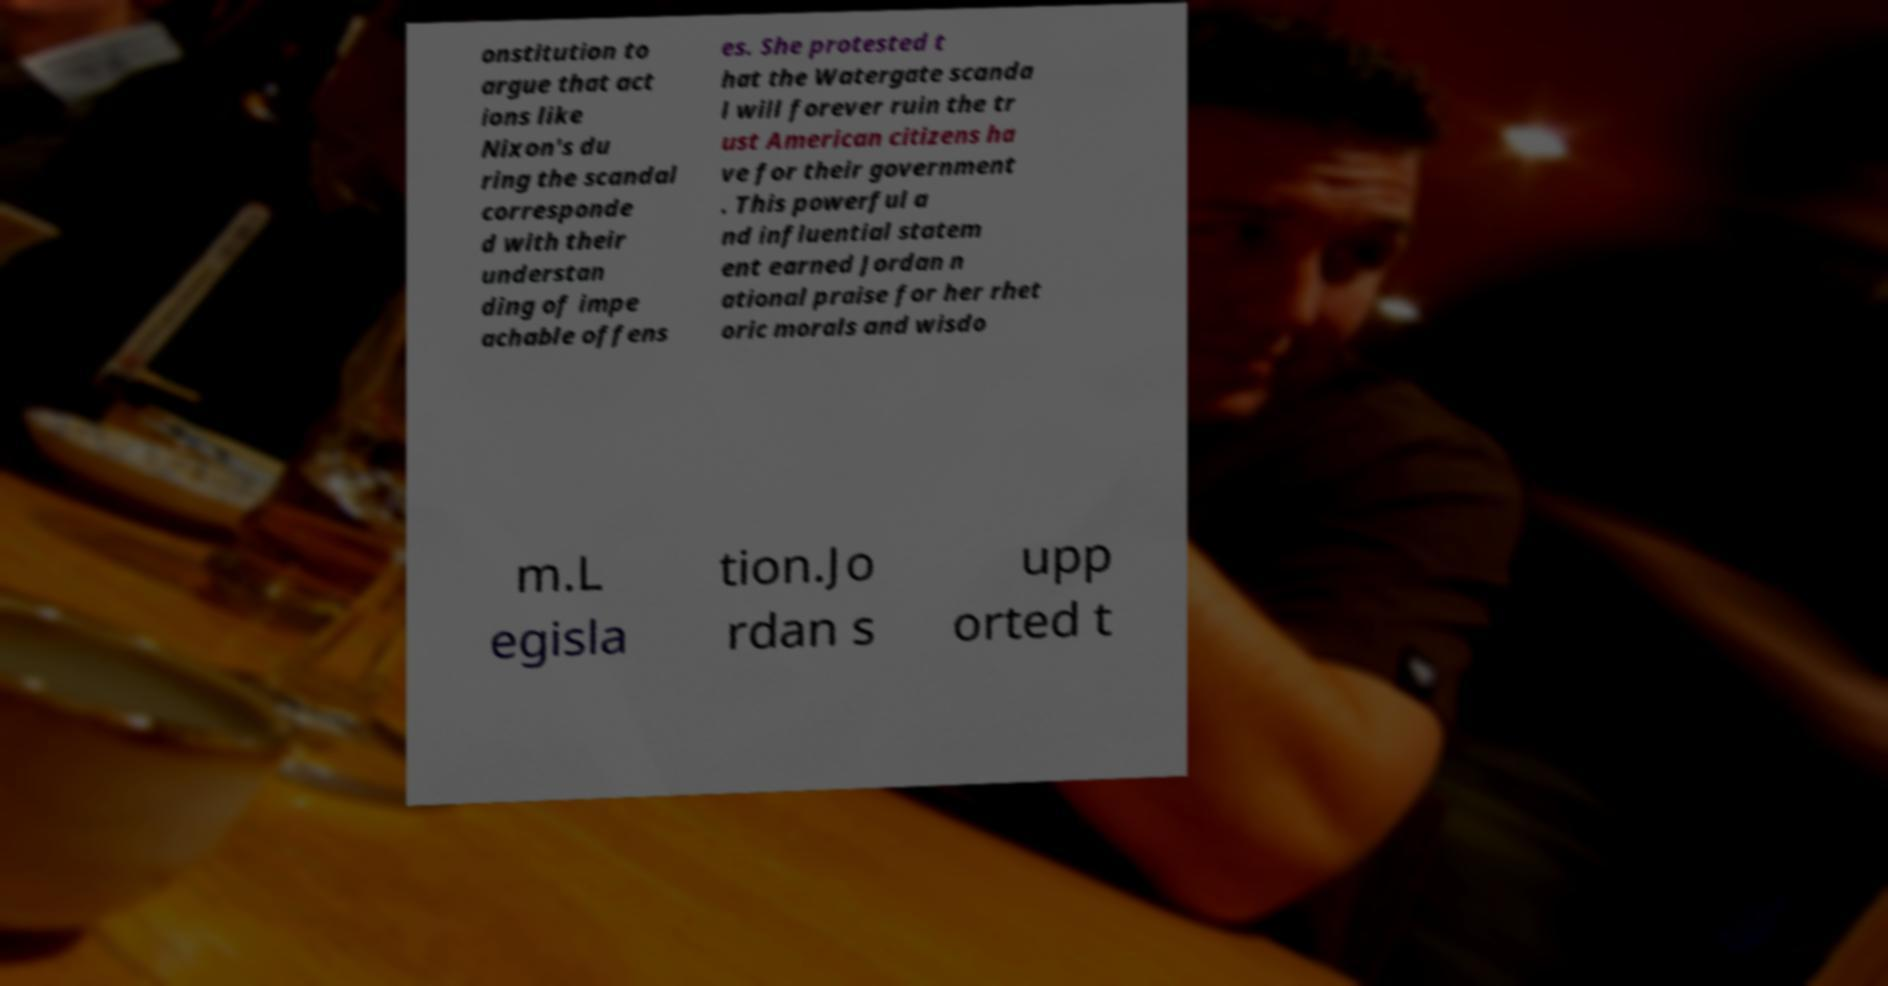I need the written content from this picture converted into text. Can you do that? onstitution to argue that act ions like Nixon's du ring the scandal corresponde d with their understan ding of impe achable offens es. She protested t hat the Watergate scanda l will forever ruin the tr ust American citizens ha ve for their government . This powerful a nd influential statem ent earned Jordan n ational praise for her rhet oric morals and wisdo m.L egisla tion.Jo rdan s upp orted t 